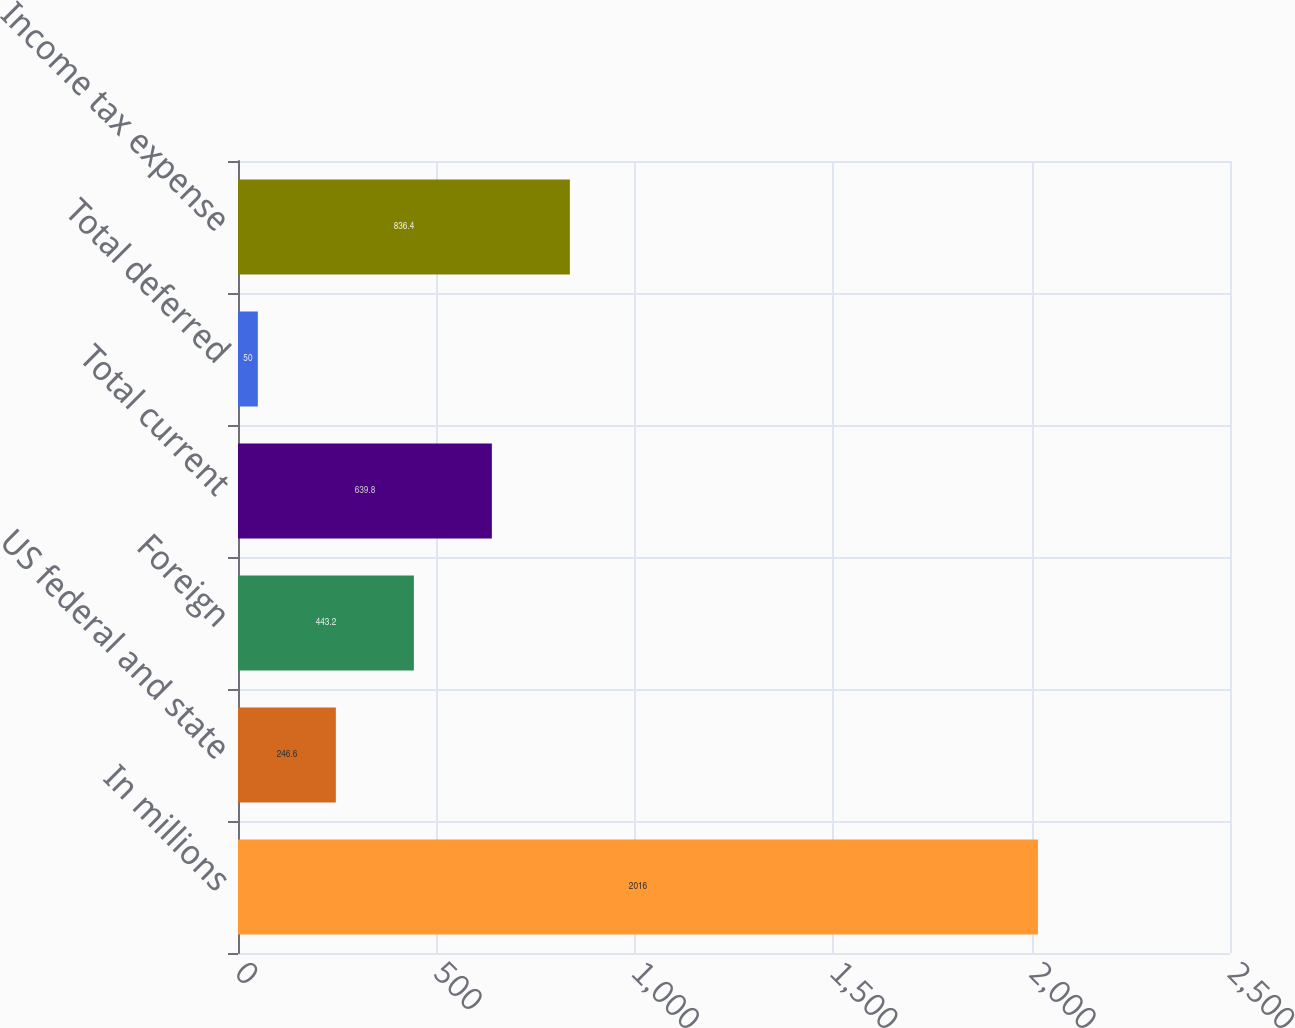Convert chart. <chart><loc_0><loc_0><loc_500><loc_500><bar_chart><fcel>In millions<fcel>US federal and state<fcel>Foreign<fcel>Total current<fcel>Total deferred<fcel>Income tax expense<nl><fcel>2016<fcel>246.6<fcel>443.2<fcel>639.8<fcel>50<fcel>836.4<nl></chart> 